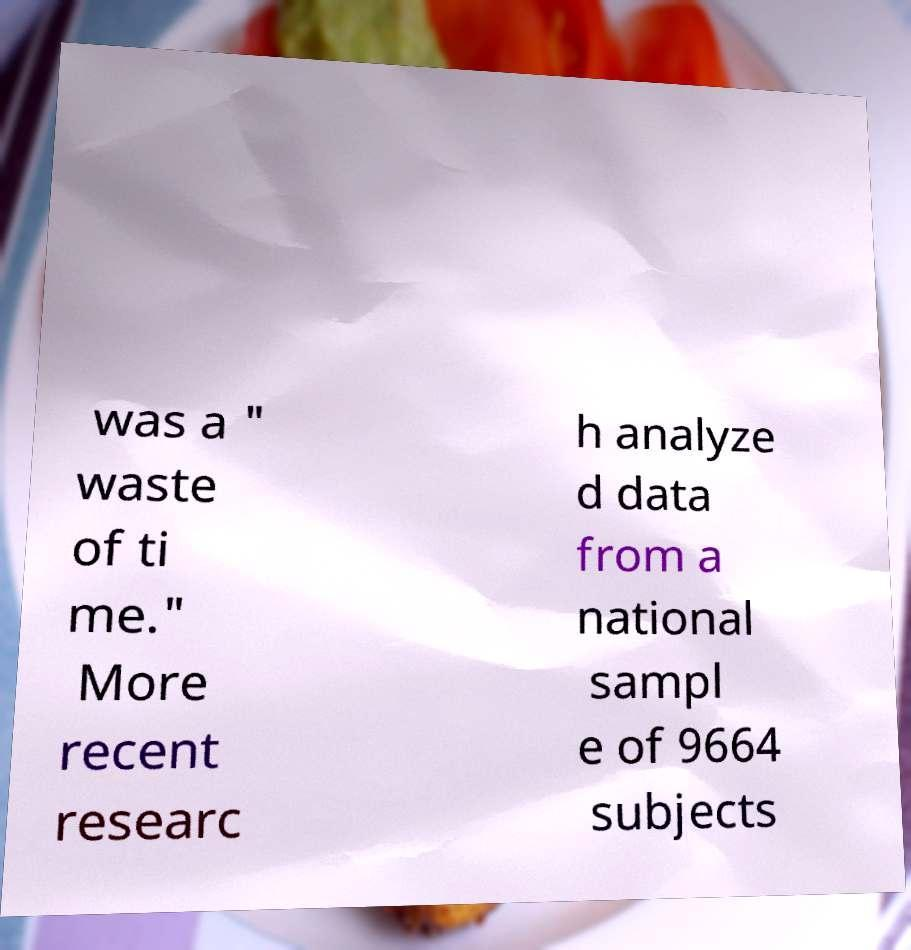Can you accurately transcribe the text from the provided image for me? was a " waste of ti me." More recent researc h analyze d data from a national sampl e of 9664 subjects 